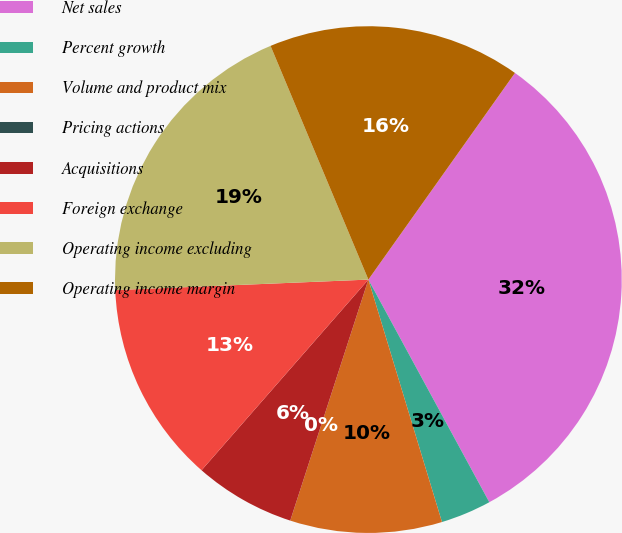<chart> <loc_0><loc_0><loc_500><loc_500><pie_chart><fcel>Net sales<fcel>Percent growth<fcel>Volume and product mix<fcel>Pricing actions<fcel>Acquisitions<fcel>Foreign exchange<fcel>Operating income excluding<fcel>Operating income margin<nl><fcel>32.26%<fcel>3.23%<fcel>9.68%<fcel>0.0%<fcel>6.45%<fcel>12.9%<fcel>19.35%<fcel>16.13%<nl></chart> 